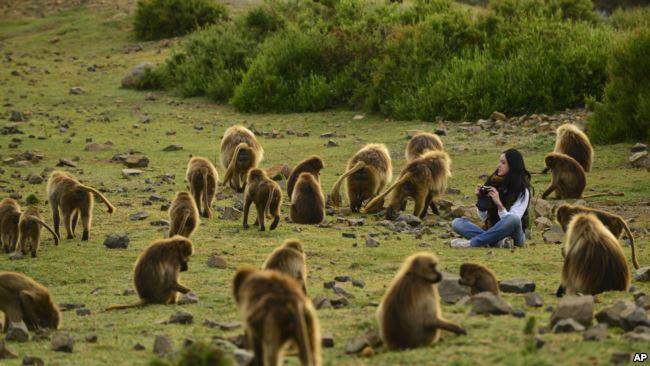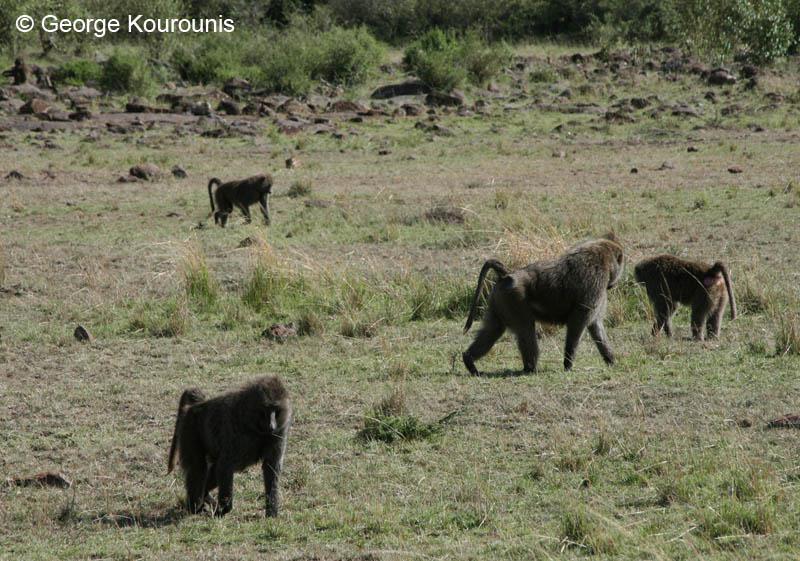The first image is the image on the left, the second image is the image on the right. For the images displayed, is the sentence "In one image there are multiple monkeys sitting in grass." factually correct? Answer yes or no. Yes. The first image is the image on the left, the second image is the image on the right. Analyze the images presented: Is the assertion "There are less than ten monkeys in the image on the right." valid? Answer yes or no. Yes. 